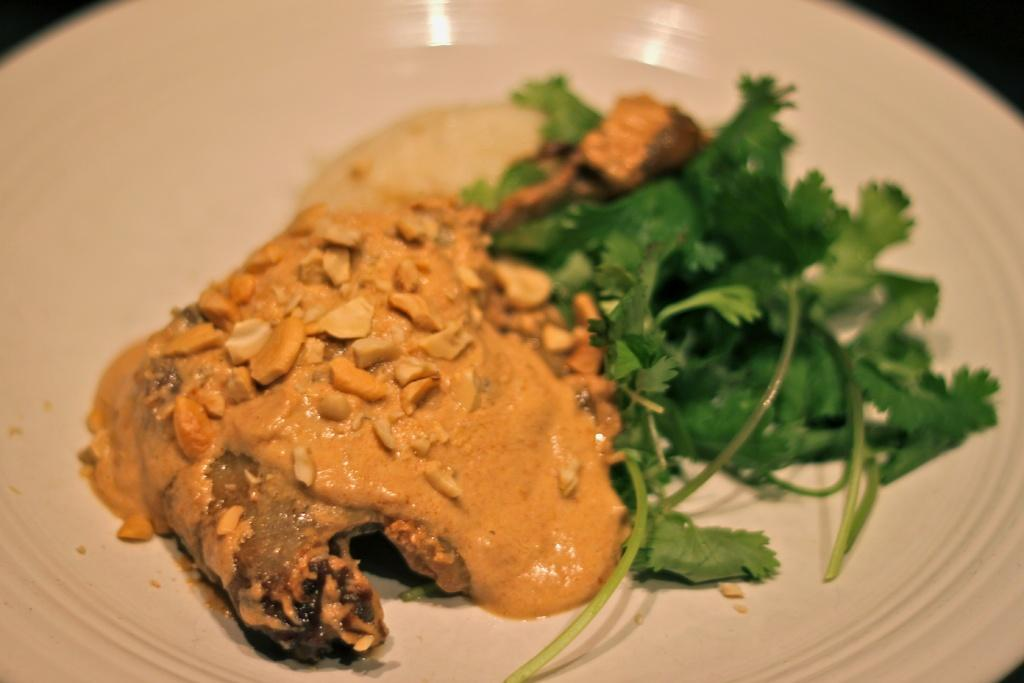What is on the plate that is visible in the image? There is a plate with food in the image. What color is the plate? The plate is white. What colors can be seen in the food on the plate? The food has yellow, green, and cream colors. What color is the background of the image? The background of the image is black. Reasoning: Let'ing: Let's think step by step in order to produce the conversation. We start by identifying the main subject in the image, which is the plate with food. Then, we expand the conversation to include details about the plate's color and the colors of the food. Finally, we describe the background color of the image. Each question is designed to elicit a specific detail about the image that is known from the provided facts. Absurd Question/Answer: Can you see any veins in the food on the plate? There are no veins present in the food on the plate, as it is not a living organism. Is there a railway visible in the image? There is no railway present in the image; it only features a plate with food and a black background. How many eggs are present in the image? There are no eggs visible in the image; it only features a plate with food and a black background. 